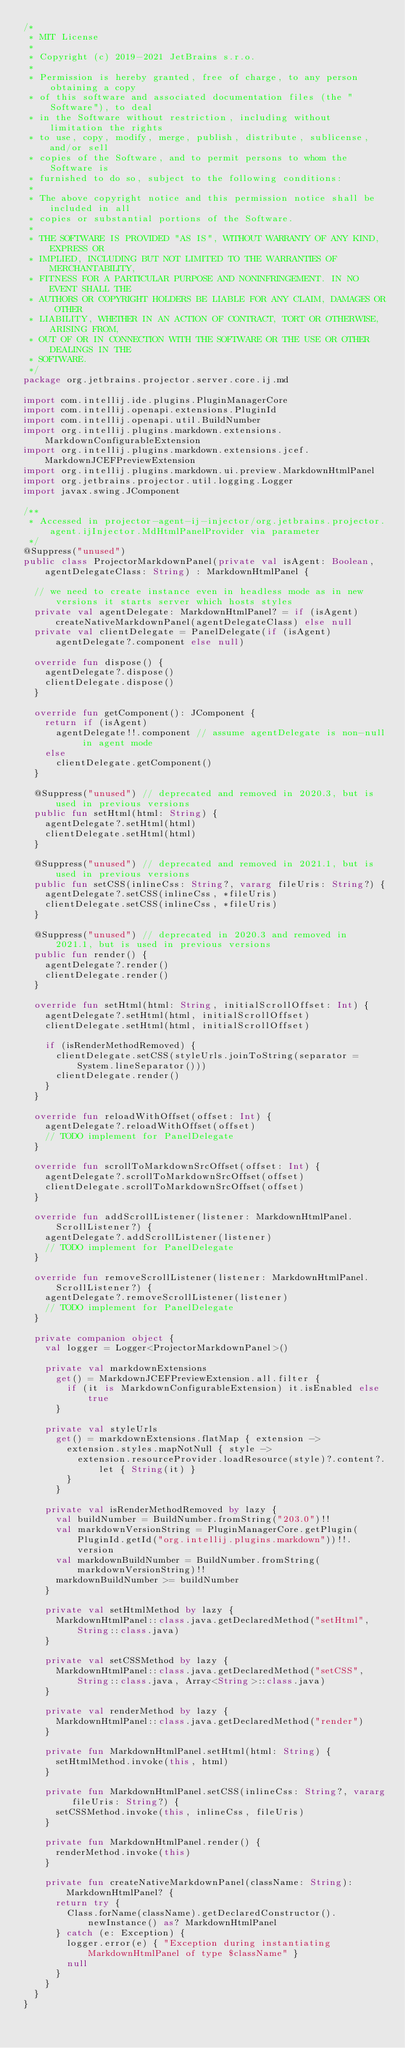<code> <loc_0><loc_0><loc_500><loc_500><_Kotlin_>/*
 * MIT License
 *
 * Copyright (c) 2019-2021 JetBrains s.r.o.
 *
 * Permission is hereby granted, free of charge, to any person obtaining a copy
 * of this software and associated documentation files (the "Software"), to deal
 * in the Software without restriction, including without limitation the rights
 * to use, copy, modify, merge, publish, distribute, sublicense, and/or sell
 * copies of the Software, and to permit persons to whom the Software is
 * furnished to do so, subject to the following conditions:
 *
 * The above copyright notice and this permission notice shall be included in all
 * copies or substantial portions of the Software.
 *
 * THE SOFTWARE IS PROVIDED "AS IS", WITHOUT WARRANTY OF ANY KIND, EXPRESS OR
 * IMPLIED, INCLUDING BUT NOT LIMITED TO THE WARRANTIES OF MERCHANTABILITY,
 * FITNESS FOR A PARTICULAR PURPOSE AND NONINFRINGEMENT. IN NO EVENT SHALL THE
 * AUTHORS OR COPYRIGHT HOLDERS BE LIABLE FOR ANY CLAIM, DAMAGES OR OTHER
 * LIABILITY, WHETHER IN AN ACTION OF CONTRACT, TORT OR OTHERWISE, ARISING FROM,
 * OUT OF OR IN CONNECTION WITH THE SOFTWARE OR THE USE OR OTHER DEALINGS IN THE
 * SOFTWARE.
 */
package org.jetbrains.projector.server.core.ij.md

import com.intellij.ide.plugins.PluginManagerCore
import com.intellij.openapi.extensions.PluginId
import com.intellij.openapi.util.BuildNumber
import org.intellij.plugins.markdown.extensions.MarkdownConfigurableExtension
import org.intellij.plugins.markdown.extensions.jcef.MarkdownJCEFPreviewExtension
import org.intellij.plugins.markdown.ui.preview.MarkdownHtmlPanel
import org.jetbrains.projector.util.logging.Logger
import javax.swing.JComponent

/**
 * Accessed in projector-agent-ij-injector/org.jetbrains.projector.agent.ijInjector.MdHtmlPanelProvider via parameter
 */
@Suppress("unused")
public class ProjectorMarkdownPanel(private val isAgent: Boolean, agentDelegateClass: String) : MarkdownHtmlPanel {

  // we need to create instance even in headless mode as in new versions it starts server which hosts styles
  private val agentDelegate: MarkdownHtmlPanel? = if (isAgent) createNativeMarkdownPanel(agentDelegateClass) else null
  private val clientDelegate = PanelDelegate(if (isAgent) agentDelegate?.component else null)

  override fun dispose() {
    agentDelegate?.dispose()
    clientDelegate.dispose()
  }

  override fun getComponent(): JComponent {
    return if (isAgent)
      agentDelegate!!.component // assume agentDelegate is non-null in agent mode
    else
      clientDelegate.getComponent()
  }

  @Suppress("unused") // deprecated and removed in 2020.3, but is used in previous versions
  public fun setHtml(html: String) {
    agentDelegate?.setHtml(html)
    clientDelegate.setHtml(html)
  }

  @Suppress("unused") // deprecated and removed in 2021.1, but is used in previous versions
  public fun setCSS(inlineCss: String?, vararg fileUris: String?) {
    agentDelegate?.setCSS(inlineCss, *fileUris)
    clientDelegate.setCSS(inlineCss, *fileUris)
  }

  @Suppress("unused") // deprecated in 2020.3 and removed in 2021.1, but is used in previous versions
  public fun render() {
    agentDelegate?.render()
    clientDelegate.render()
  }

  override fun setHtml(html: String, initialScrollOffset: Int) {
    agentDelegate?.setHtml(html, initialScrollOffset)
    clientDelegate.setHtml(html, initialScrollOffset)

    if (isRenderMethodRemoved) {
      clientDelegate.setCSS(styleUrls.joinToString(separator = System.lineSeparator()))
      clientDelegate.render()
    }
  }

  override fun reloadWithOffset(offset: Int) {
    agentDelegate?.reloadWithOffset(offset)
    // TODO implement for PanelDelegate
  }

  override fun scrollToMarkdownSrcOffset(offset: Int) {
    agentDelegate?.scrollToMarkdownSrcOffset(offset)
    clientDelegate.scrollToMarkdownSrcOffset(offset)
  }

  override fun addScrollListener(listener: MarkdownHtmlPanel.ScrollListener?) {
    agentDelegate?.addScrollListener(listener)
    // TODO implement for PanelDelegate
  }

  override fun removeScrollListener(listener: MarkdownHtmlPanel.ScrollListener?) {
    agentDelegate?.removeScrollListener(listener)
    // TODO implement for PanelDelegate
  }

  private companion object {
    val logger = Logger<ProjectorMarkdownPanel>()

    private val markdownExtensions
      get() = MarkdownJCEFPreviewExtension.all.filter {
        if (it is MarkdownConfigurableExtension) it.isEnabled else true
      }

    private val styleUrls
      get() = markdownExtensions.flatMap { extension ->
        extension.styles.mapNotNull { style ->
          extension.resourceProvider.loadResource(style)?.content?.let { String(it) }
        }
      }

    private val isRenderMethodRemoved by lazy {
      val buildNumber = BuildNumber.fromString("203.0")!!
      val markdownVersionString = PluginManagerCore.getPlugin(PluginId.getId("org.intellij.plugins.markdown"))!!.version
      val markdownBuildNumber = BuildNumber.fromString(markdownVersionString)!!
      markdownBuildNumber >= buildNumber
    }

    private val setHtmlMethod by lazy {
      MarkdownHtmlPanel::class.java.getDeclaredMethod("setHtml", String::class.java)
    }

    private val setCSSMethod by lazy {
      MarkdownHtmlPanel::class.java.getDeclaredMethod("setCSS", String::class.java, Array<String>::class.java)
    }

    private val renderMethod by lazy {
      MarkdownHtmlPanel::class.java.getDeclaredMethod("render")
    }

    private fun MarkdownHtmlPanel.setHtml(html: String) {
      setHtmlMethod.invoke(this, html)
    }

    private fun MarkdownHtmlPanel.setCSS(inlineCss: String?, vararg fileUris: String?) {
      setCSSMethod.invoke(this, inlineCss, fileUris)
    }

    private fun MarkdownHtmlPanel.render() {
      renderMethod.invoke(this)
    }

    private fun createNativeMarkdownPanel(className: String): MarkdownHtmlPanel? {
      return try {
        Class.forName(className).getDeclaredConstructor().newInstance() as? MarkdownHtmlPanel
      } catch (e: Exception) {
        logger.error(e) { "Exception during instantiating MarkdownHtmlPanel of type $className" }
        null
      }
    }
  }
}
</code> 